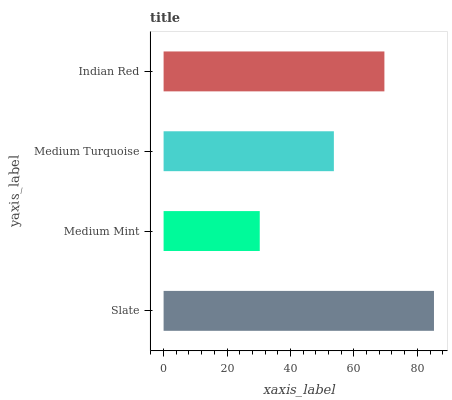Is Medium Mint the minimum?
Answer yes or no. Yes. Is Slate the maximum?
Answer yes or no. Yes. Is Medium Turquoise the minimum?
Answer yes or no. No. Is Medium Turquoise the maximum?
Answer yes or no. No. Is Medium Turquoise greater than Medium Mint?
Answer yes or no. Yes. Is Medium Mint less than Medium Turquoise?
Answer yes or no. Yes. Is Medium Mint greater than Medium Turquoise?
Answer yes or no. No. Is Medium Turquoise less than Medium Mint?
Answer yes or no. No. Is Indian Red the high median?
Answer yes or no. Yes. Is Medium Turquoise the low median?
Answer yes or no. Yes. Is Medium Mint the high median?
Answer yes or no. No. Is Medium Mint the low median?
Answer yes or no. No. 